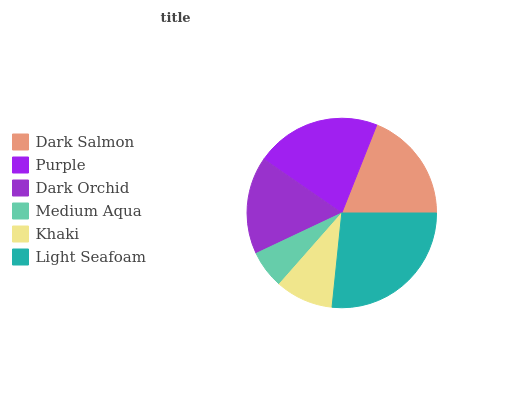Is Medium Aqua the minimum?
Answer yes or no. Yes. Is Light Seafoam the maximum?
Answer yes or no. Yes. Is Purple the minimum?
Answer yes or no. No. Is Purple the maximum?
Answer yes or no. No. Is Purple greater than Dark Salmon?
Answer yes or no. Yes. Is Dark Salmon less than Purple?
Answer yes or no. Yes. Is Dark Salmon greater than Purple?
Answer yes or no. No. Is Purple less than Dark Salmon?
Answer yes or no. No. Is Dark Salmon the high median?
Answer yes or no. Yes. Is Dark Orchid the low median?
Answer yes or no. Yes. Is Medium Aqua the high median?
Answer yes or no. No. Is Purple the low median?
Answer yes or no. No. 